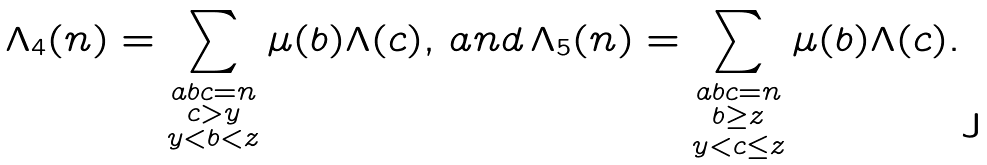Convert formula to latex. <formula><loc_0><loc_0><loc_500><loc_500>\Lambda _ { 4 } ( n ) = \sum _ { \substack { a b c = n \\ c > y \\ y < b < z } } \mu ( b ) \Lambda ( c ) , \, a n d \, \Lambda _ { 5 } ( n ) = \sum _ { \substack { a b c = n \\ b \geq z \\ y < c \leq z } } \mu ( b ) \Lambda ( c ) .</formula> 